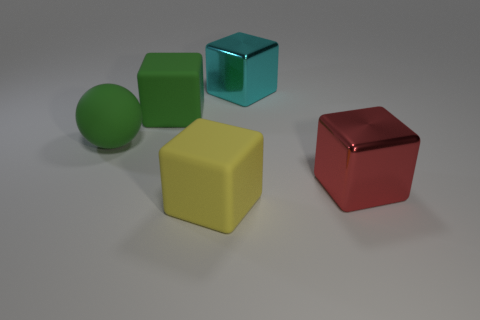There is a big block that is the same color as the ball; what material is it?
Your response must be concise. Rubber. What number of rubber blocks are the same color as the matte ball?
Provide a short and direct response. 1. Are there any shiny blocks of the same color as the large ball?
Make the answer very short. No. What number of other things are made of the same material as the cyan block?
Ensure brevity in your answer.  1. Do the matte sphere and the matte object that is behind the large rubber sphere have the same color?
Give a very brief answer. Yes. Are there more big cyan metallic objects that are behind the large red block than big green cylinders?
Keep it short and to the point. Yes. What number of yellow objects are right of the green matte block that is behind the big matte thing that is in front of the big matte ball?
Your answer should be compact. 1. Do the big matte thing in front of the large red thing and the cyan object have the same shape?
Your answer should be very brief. Yes. What material is the thing that is in front of the red cube?
Offer a very short reply. Rubber. What shape is the large object that is both in front of the big rubber sphere and left of the red metal cube?
Make the answer very short. Cube. 